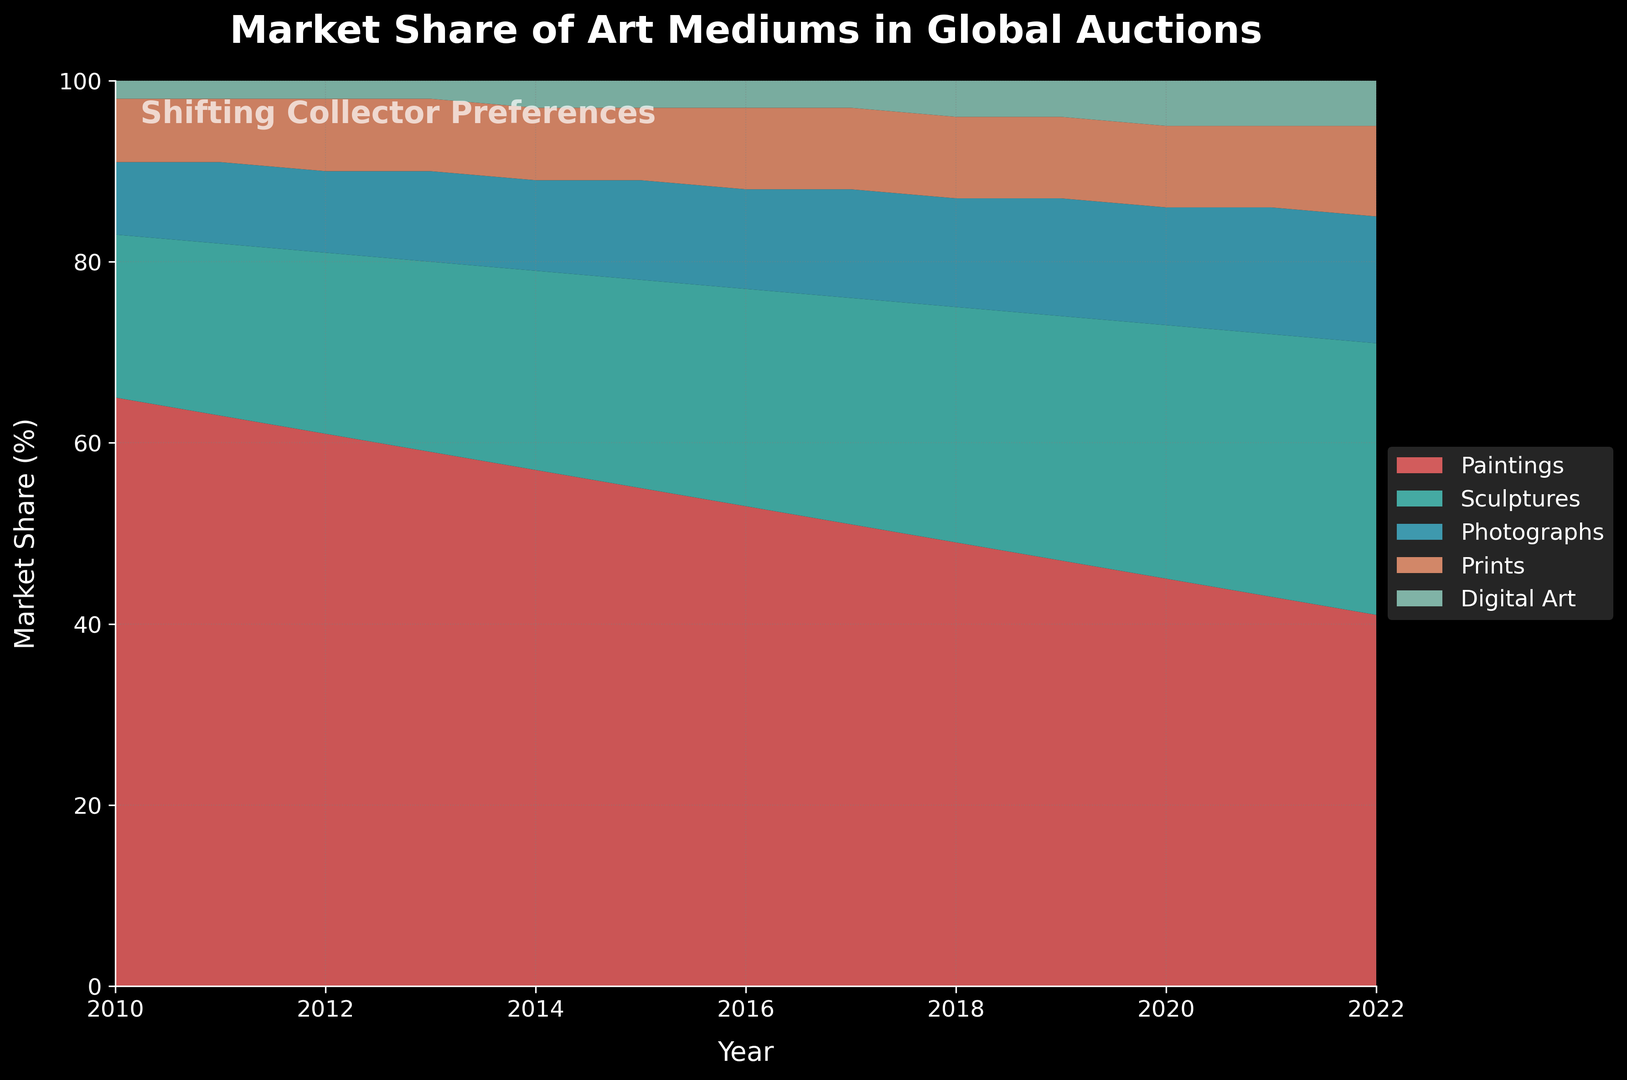What is the overall trend for market share of paintings from 2010 to 2022? The market share of paintings shows a consistent decline over the years. Starting from 65% in 2010, it decreases to 41% in 2022.
Answer: Declining Which art medium's market share has remained constant from 2010 to 2022? Digital Art market share remained constant at 2% to 3% from 2010 to 2015 and then slowly increased to 5% by 2022.
Answer: Digital Art In what year did sculptures surpass 25% market share? By looking at the graph, sculptures first surpass the 25% market share in the year 2017.
Answer: 2017 How does the market share of prints change from 2010 to 2022? Prints consistently maintained an 8% share until 2016, after which it slightly increased to 9% and finally to 10% in the last few years.
Answer: Slightly increasing Which art medium had the most significant increase in market share from 2010 to 2022? Sculptures exhibit the most significant increase, from 18% in 2010 to 30% in 2022, showing a growth of 12%.
Answer: Sculptures What is the combined market share of photographs and digital art in 2018? In 2018, the market share of photographs is 12% and digital art is 4%. The combined market share is 12% + 4%.
Answer: 16% How does the market share of digital art compare to that of sculptures in 2022? In 2022, the market share of digital art is 5%, while that of sculptures is 30%. Sculptures have a significantly higher market share compared to digital art.
Answer: Sculptures are higher Which two art mediums had equal market share in any given year, and what was that year? Paintings and sculptures had an equal market share of 41% each in 2022.
Answer: 2022 What was the market share difference between sculptures and prints in 2020? In 2020, the market share of sculptures is 28%, and prints are 9%. The difference is 28% - 9%.
Answer: 19% What trend can you observe for the market share of photographs from 2010 to 2022? The market share of photographs shows a gradual increase from 8% in 2010 to 14% in 2022.
Answer: Increasing 